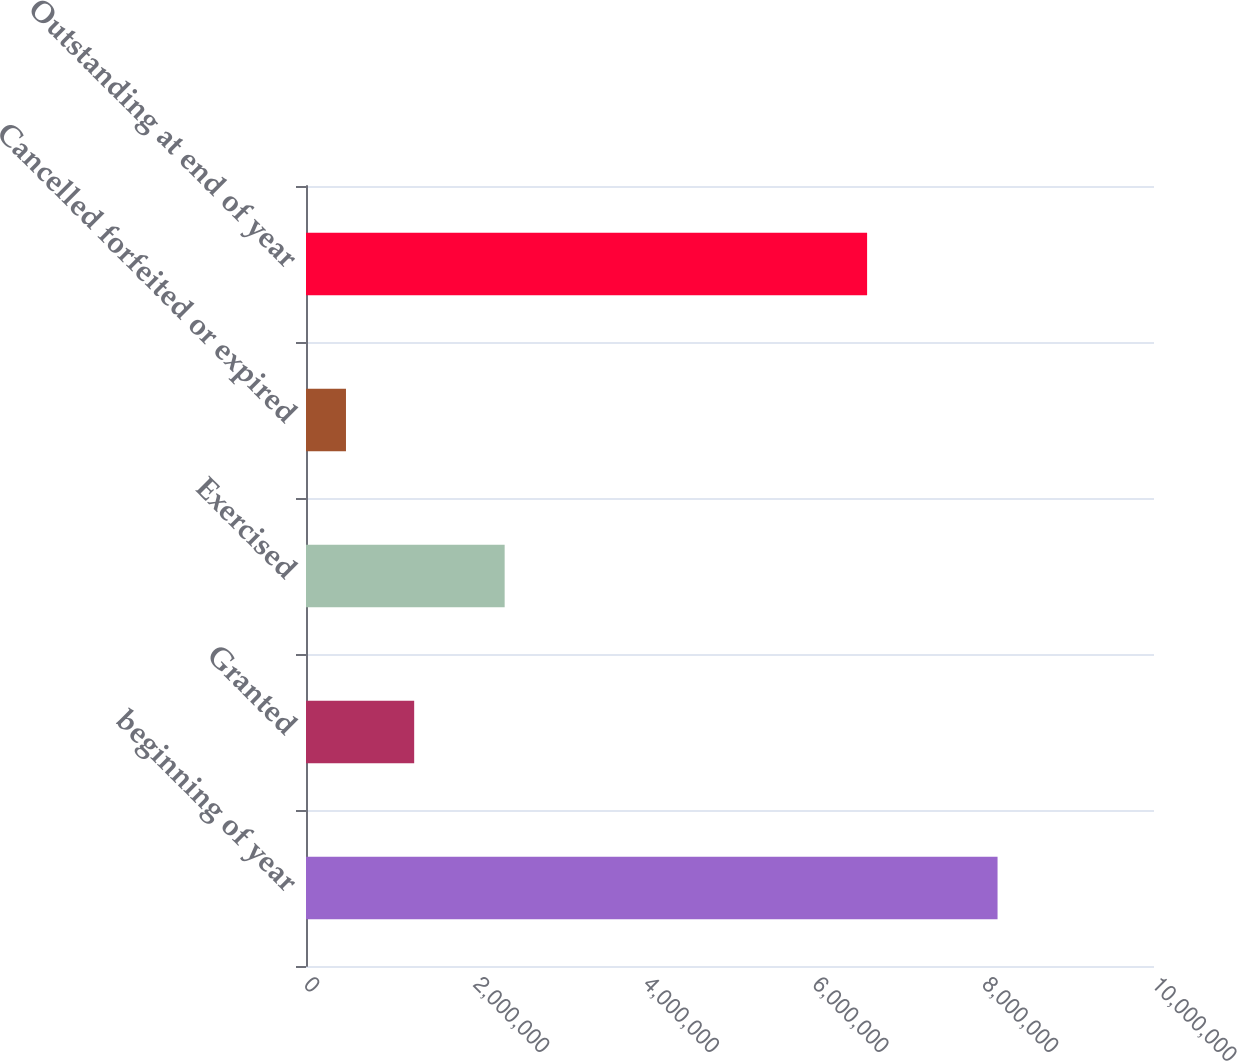Convert chart. <chart><loc_0><loc_0><loc_500><loc_500><bar_chart><fcel>beginning of year<fcel>Granted<fcel>Exercised<fcel>Cancelled forfeited or expired<fcel>Outstanding at end of year<nl><fcel>8.1551e+06<fcel>1.2757e+06<fcel>2.3426e+06<fcel>471400<fcel>6.6168e+06<nl></chart> 